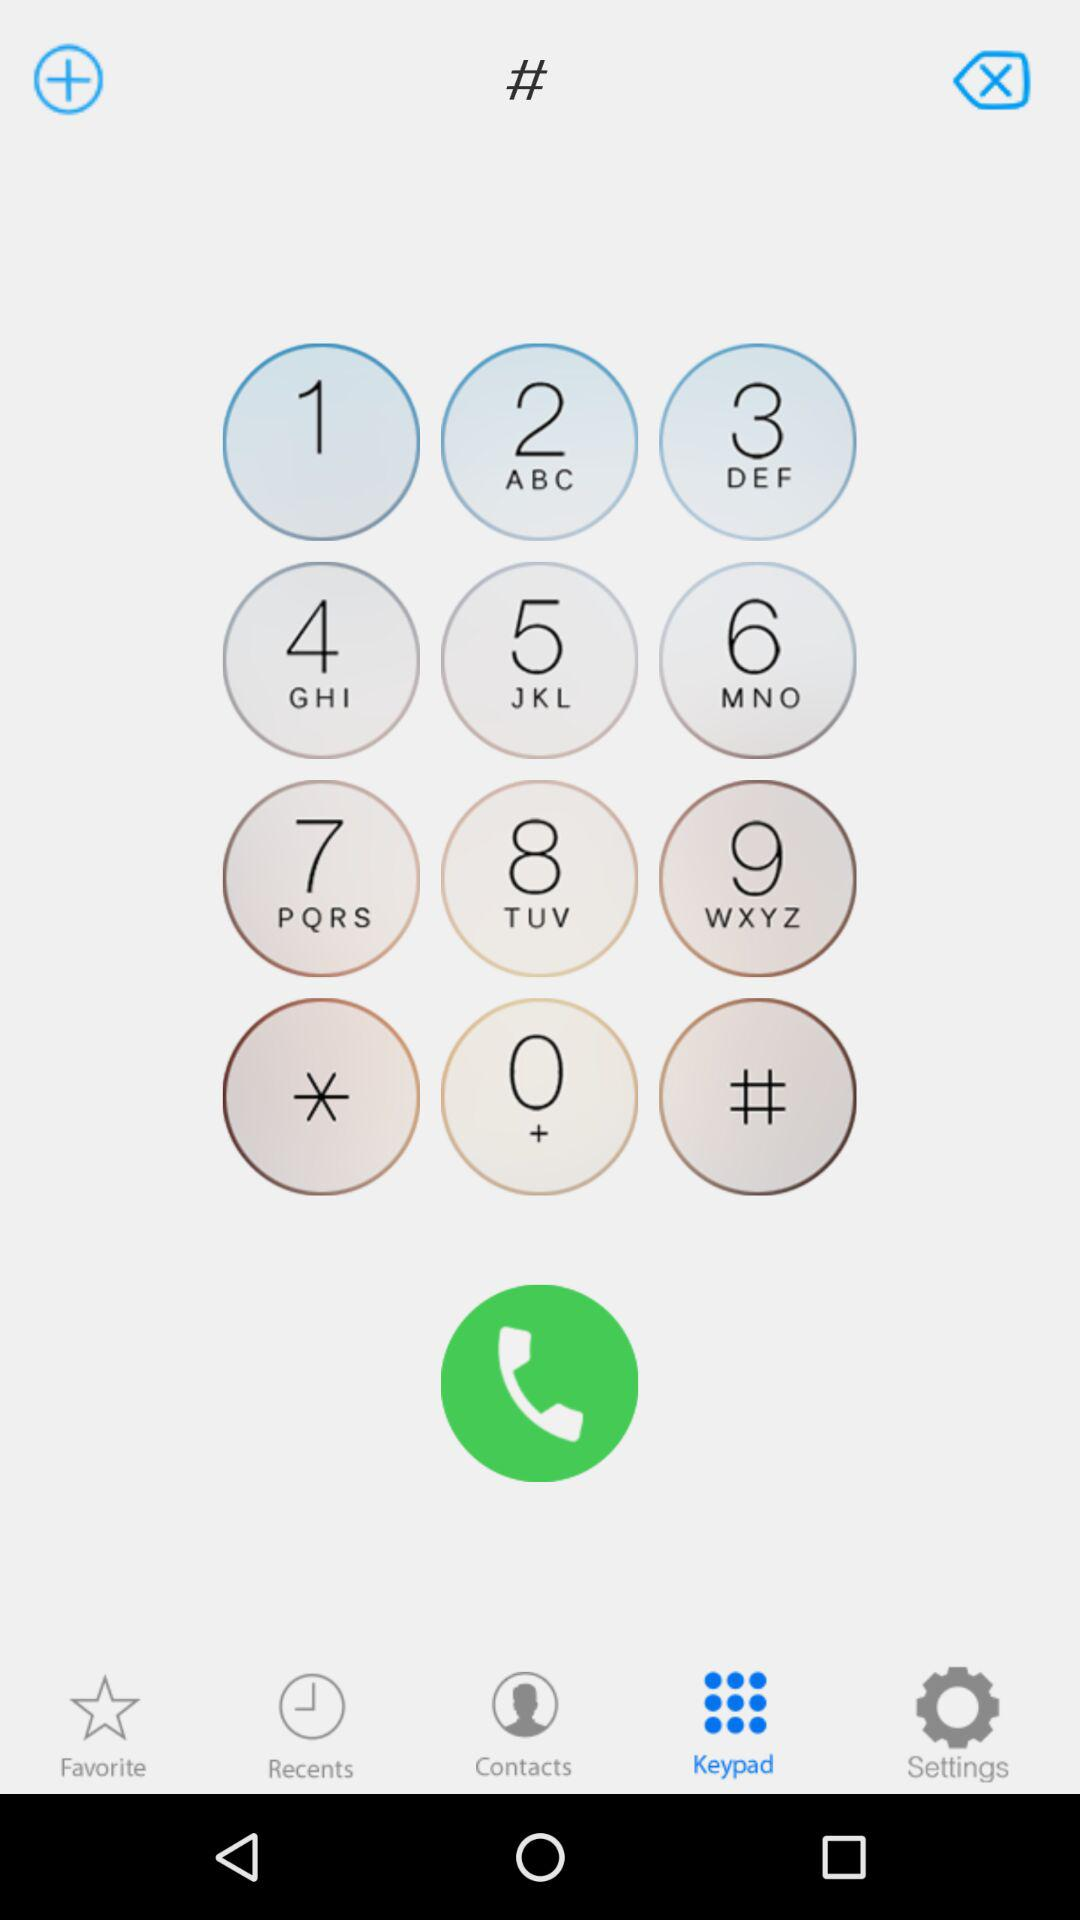How many notifications are there in "Settings"?
When the provided information is insufficient, respond with <no answer>. <no answer> 